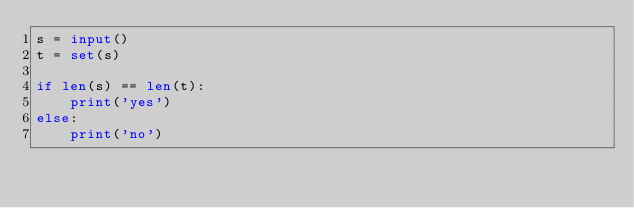<code> <loc_0><loc_0><loc_500><loc_500><_Python_>s = input()
t = set(s)

if len(s) == len(t):
    print('yes')
else:
    print('no')
</code> 